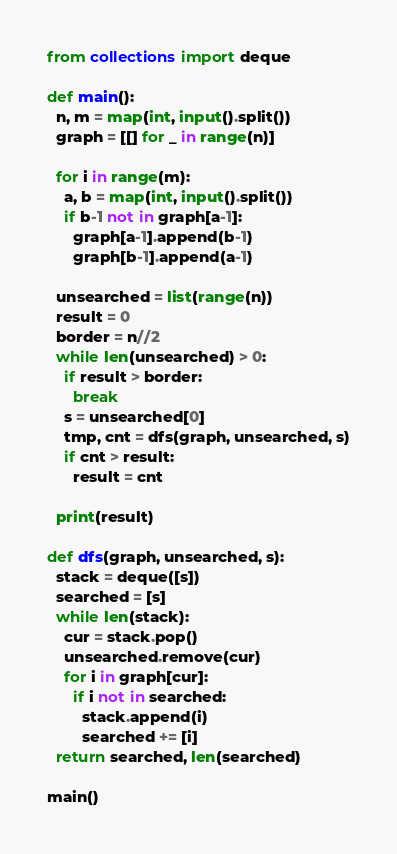<code> <loc_0><loc_0><loc_500><loc_500><_Python_>from collections import deque

def main():
  n, m = map(int, input().split())
  graph = [[] for _ in range(n)]

  for i in range(m):
    a, b = map(int, input().split())
    if b-1 not in graph[a-1]:
      graph[a-1].append(b-1)
      graph[b-1].append(a-1)
  
  unsearched = list(range(n))
  result = 0
  border = n//2
  while len(unsearched) > 0:
    if result > border:
      break
    s = unsearched[0]
    tmp, cnt = dfs(graph, unsearched, s)
    if cnt > result:
      result = cnt
      
  print(result)

def dfs(graph, unsearched, s):
  stack = deque([s])
  searched = [s]
  while len(stack):
    cur = stack.pop()
    unsearched.remove(cur)
    for i in graph[cur]:
      if i not in searched:
        stack.append(i)
        searched += [i]
  return searched, len(searched)

main()</code> 